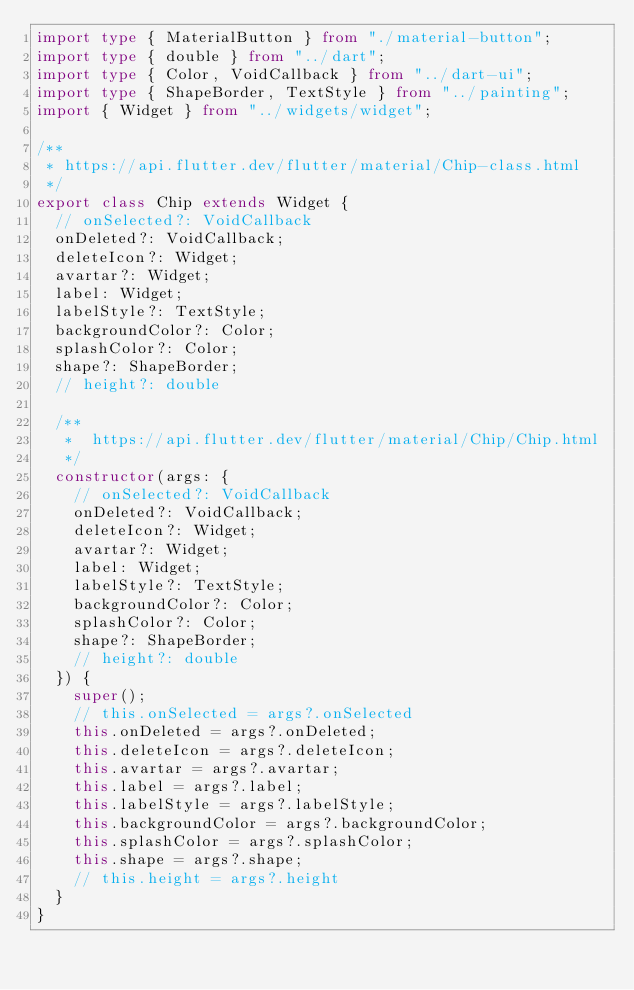Convert code to text. <code><loc_0><loc_0><loc_500><loc_500><_TypeScript_>import type { MaterialButton } from "./material-button";
import type { double } from "../dart";
import type { Color, VoidCallback } from "../dart-ui";
import type { ShapeBorder, TextStyle } from "../painting";
import { Widget } from "../widgets/widget";

/**
 * https://api.flutter.dev/flutter/material/Chip-class.html
 */
export class Chip extends Widget {
  // onSelected?: VoidCallback
  onDeleted?: VoidCallback;
  deleteIcon?: Widget;
  avartar?: Widget;
  label: Widget;
  labelStyle?: TextStyle;
  backgroundColor?: Color;
  splashColor?: Color;
  shape?: ShapeBorder;
  // height?: double

  /**
   *  https://api.flutter.dev/flutter/material/Chip/Chip.html
   */
  constructor(args: {
    // onSelected?: VoidCallback
    onDeleted?: VoidCallback;
    deleteIcon?: Widget;
    avartar?: Widget;
    label: Widget;
    labelStyle?: TextStyle;
    backgroundColor?: Color;
    splashColor?: Color;
    shape?: ShapeBorder;
    // height?: double
  }) {
    super();
    // this.onSelected = args?.onSelected
    this.onDeleted = args?.onDeleted;
    this.deleteIcon = args?.deleteIcon;
    this.avartar = args?.avartar;
    this.label = args?.label;
    this.labelStyle = args?.labelStyle;
    this.backgroundColor = args?.backgroundColor;
    this.splashColor = args?.splashColor;
    this.shape = args?.shape;
    // this.height = args?.height
  }
}
</code> 